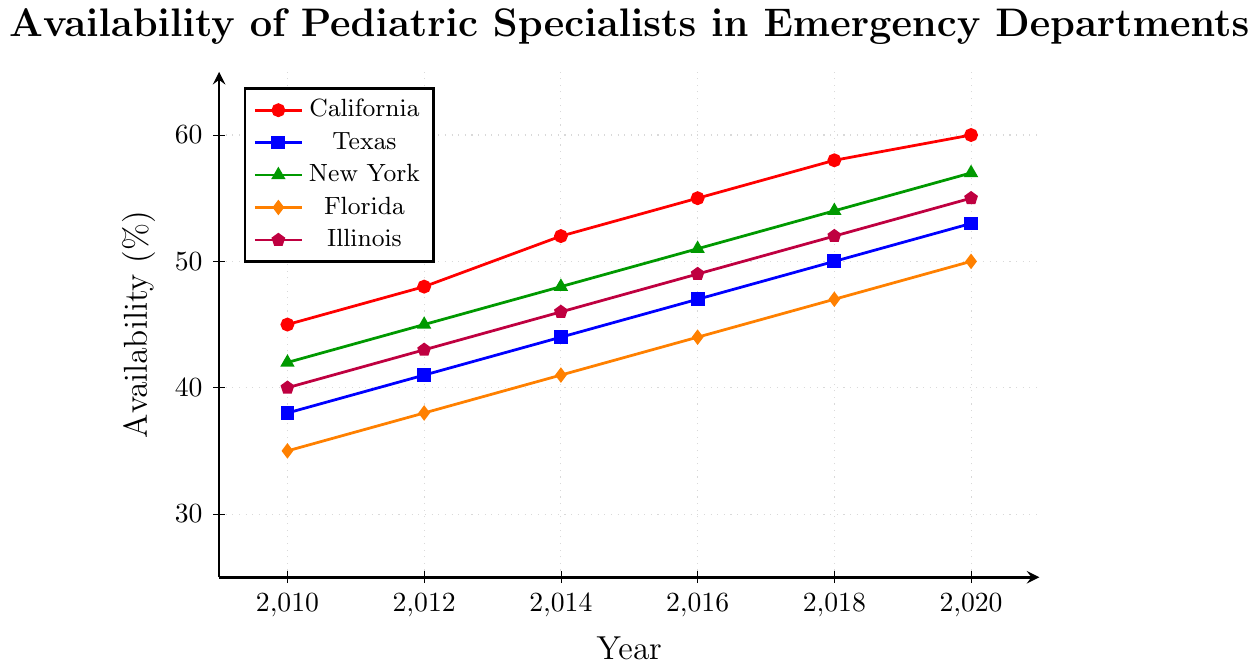What state had the highest availability of pediatric specialists in 2020? Look at the plot and identify the state line that reaches the highest value on the y-axis for the year 2020. The red line for California reaches 60%.
Answer: California What was the increase in availability of pediatric specialists in Texas from 2010 to 2020? Look at the blue line representing Texas. The values in 2010 and 2020 are 38% and 53%, respectively. The increase is 53% - 38% = 15%.
Answer: 15% Between Illinois and Florida, which state had a higher percentage of availability in 2012? Compare the values for Illinois and Florida in 2012. Illinois (purple) has 43%, and Florida (orange) has 38%.
Answer: Illinois Which state showed the steady increase in pediatric specialist availability each year from 2010 to 2020? Check for the lines that increase smoothly without dips. California (red) consistently increases from 45% to 60%.
Answer: California What was the average availability of pediatric specialists in California and New York in 2018? For California, the availability in 2018 is 58%, and for New York, it is 54%. Calculate the average: (58% + 54%) / 2 = 56%.
Answer: 56% How many states had an availability greater than 55% in 2020? Identify the lines that cross the 55% mark on the y-axis in 2020. California (60%) and Illinois (55%) both exceed 55%.
Answer: 2 Which state had the lowest availability of pediatric specialists in 2016? Find the line with the smallest y-value in 2016. The orange line for Florida is at 44%.
Answer: Florida What percentage did Illinois start at in 2010 and what was its endpoint in 2020? For Illinois (purple line), 2010 value is 40% and 2020 value is 55%.
Answer: 40% and 55% Does New York ever surpass California in terms of availability from 2010 to 2020? Compare the green line (New York) with the red line (California) throughout the plot. New York never surpasses California.
Answer: No What is the total increase in pediatric specialist availability in Florida from 2010 to 2020? Check the starting value (35%) and ending value (50%) for the orange line representing Florida. The increase is 50% - 35% = 15%.
Answer: 15% 